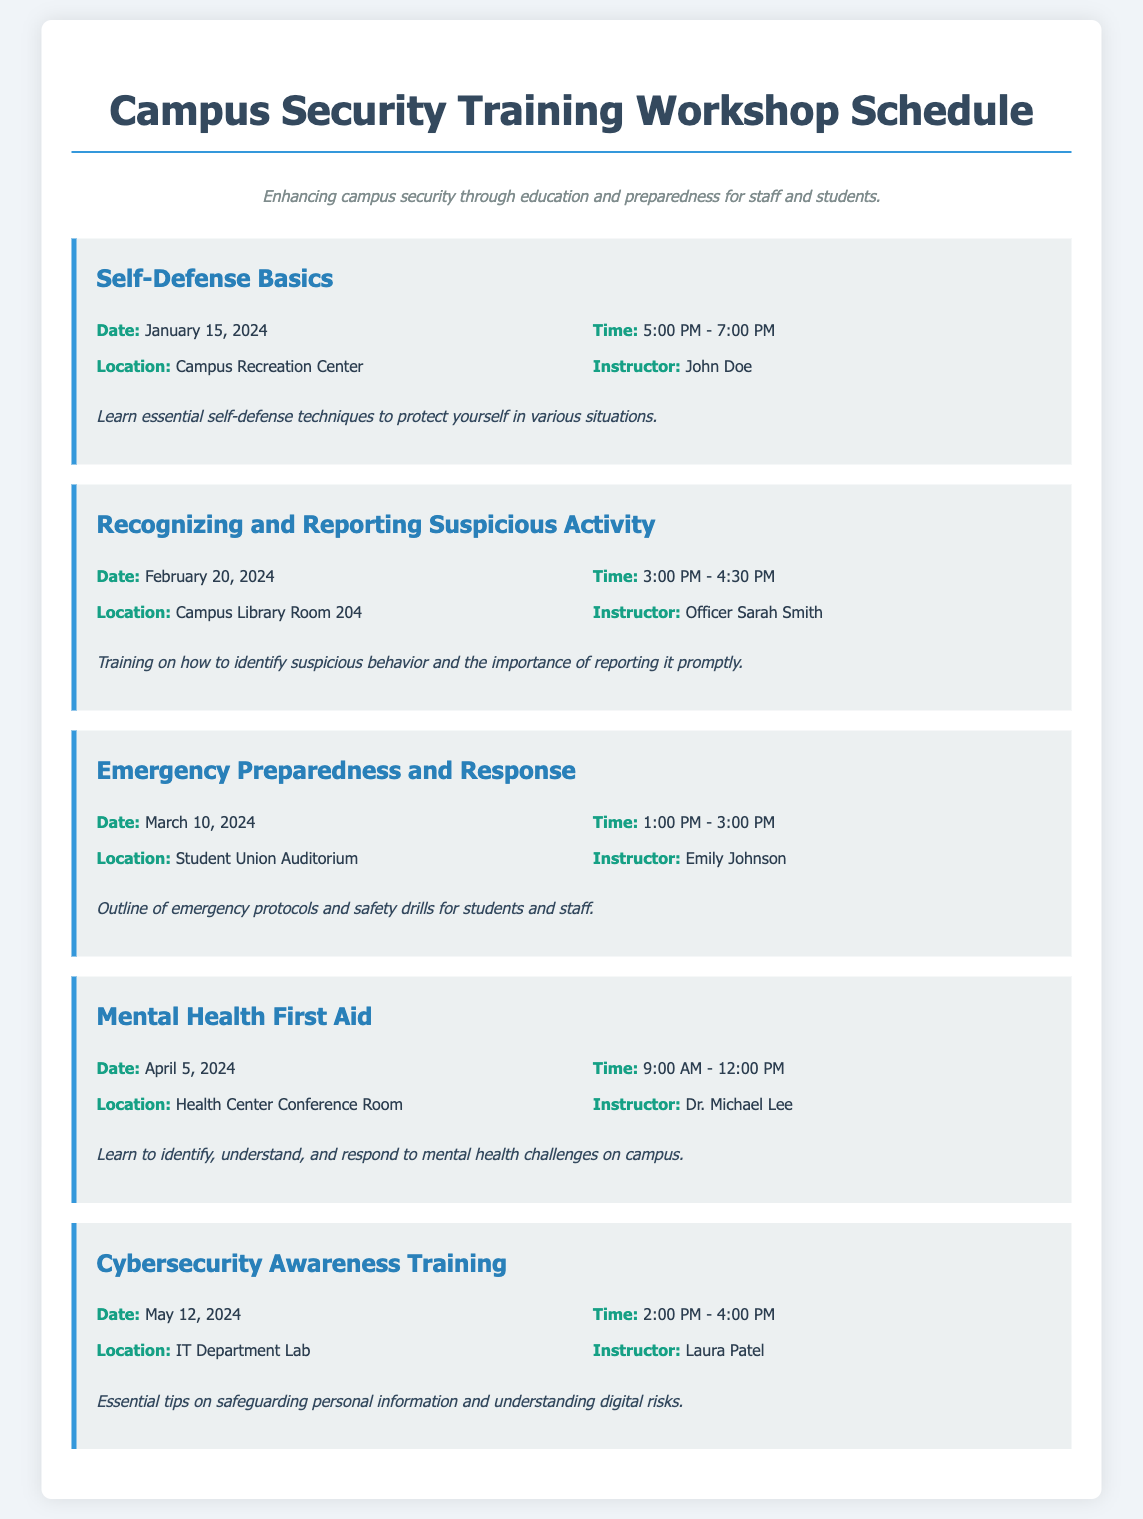What is the date of the Self-Defense Basics workshop? The date for the Self-Defense Basics workshop is mentioned in the document as January 15, 2024.
Answer: January 15, 2024 Who is the instructor for the Emergency Preparedness and Response workshop? The instructor's name for the Emergency Preparedness and Response workshop is listed as Emily Johnson.
Answer: Emily Johnson What time does the Mental Health First Aid workshop start? The starting time for the Mental Health First Aid workshop is provided in the document as 9:00 AM.
Answer: 9:00 AM Where will the Recognizing and Reporting Suspicious Activity workshop be held? The location for the Recognizing and Reporting Suspicious Activity workshop is stated as Campus Library Room 204.
Answer: Campus Library Room 204 How long is the Cybersecurity Awareness Training workshop? The duration of the Cybersecurity Awareness Training workshop can be inferred from the start and end times provided in the document, which are 2:00 PM to 4:00 PM.
Answer: 2 hours What type of training is offered on April 5, 2024? The training offered on April 5, 2024, is specified as Mental Health First Aid in the document.
Answer: Mental Health First Aid What is the purpose of the training workshops listed in the document? The document describes the purpose of the training workshops as enhancing campus security through education and preparedness for staff and students.
Answer: Enhancing campus security How many workshops are scheduled for the month of January 2024? The document lists only one workshop scheduled for January 2024, which is the Self-Defense Basics workshop.
Answer: One 